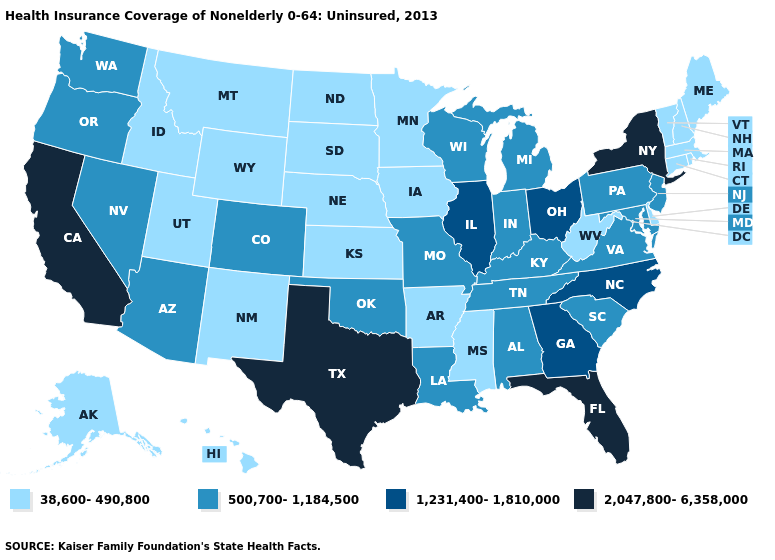What is the value of Tennessee?
Be succinct. 500,700-1,184,500. Is the legend a continuous bar?
Give a very brief answer. No. Which states have the highest value in the USA?
Keep it brief. California, Florida, New York, Texas. Among the states that border Illinois , does Iowa have the lowest value?
Keep it brief. Yes. Name the states that have a value in the range 1,231,400-1,810,000?
Quick response, please. Georgia, Illinois, North Carolina, Ohio. Does Kansas have the highest value in the USA?
Keep it brief. No. Among the states that border New York , which have the highest value?
Keep it brief. New Jersey, Pennsylvania. Name the states that have a value in the range 500,700-1,184,500?
Answer briefly. Alabama, Arizona, Colorado, Indiana, Kentucky, Louisiana, Maryland, Michigan, Missouri, Nevada, New Jersey, Oklahoma, Oregon, Pennsylvania, South Carolina, Tennessee, Virginia, Washington, Wisconsin. Among the states that border Maine , which have the highest value?
Answer briefly. New Hampshire. What is the highest value in the West ?
Give a very brief answer. 2,047,800-6,358,000. What is the highest value in states that border Tennessee?
Be succinct. 1,231,400-1,810,000. Which states have the lowest value in the Northeast?
Write a very short answer. Connecticut, Maine, Massachusetts, New Hampshire, Rhode Island, Vermont. What is the value of Vermont?
Keep it brief. 38,600-490,800. Name the states that have a value in the range 38,600-490,800?
Keep it brief. Alaska, Arkansas, Connecticut, Delaware, Hawaii, Idaho, Iowa, Kansas, Maine, Massachusetts, Minnesota, Mississippi, Montana, Nebraska, New Hampshire, New Mexico, North Dakota, Rhode Island, South Dakota, Utah, Vermont, West Virginia, Wyoming. What is the value of Idaho?
Quick response, please. 38,600-490,800. 